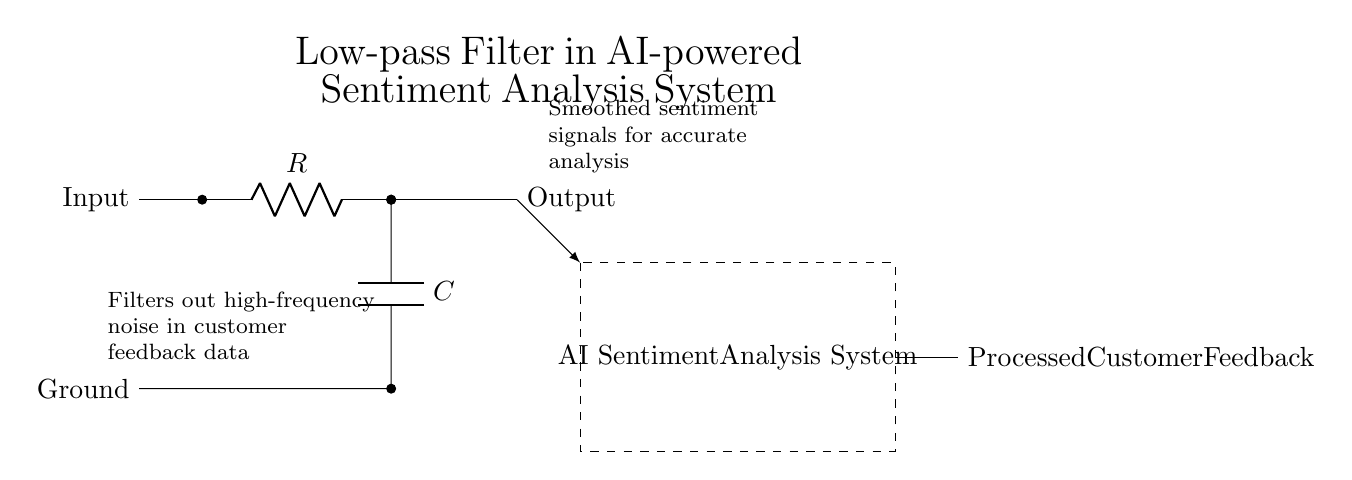What is the input of the circuit? The input is the signal that is fed into the circuit for processing. It is denoted by the label "Input" on the left side of the circuit diagram.
Answer: Input What type of components are used in this circuit? The circuit uses resistors and capacitors, specifically indicated by the symbols for an R and a C in the diagram.
Answer: Resistors and capacitors What does the dashed rectangle represent? The dashed rectangle encloses the AI Sentiment Analysis System, indicating that this is the part of the circuit where the processing occurs after the filtering.
Answer: AI Sentiment Analysis System What is the role of the capacitor in this low-pass filter? The capacitor stores and releases energy, helping smooth out the output signal by filtering out the high-frequency noise from the input signal.
Answer: To smooth the output signal How does this low-pass filter affect the feedback data? The low-pass filter removes high-frequency noise from the customer feedback data, ensuring that only lower frequency signals, which are typically more stable and relevant, are passed through to the analysis system.
Answer: Filters out high-frequency noise What is the output of this circuit? The output is the processed customer feedback that has been filtered and is ready for analysis by the AI Sentiment Analysis System, as indicated on the right side of the circuit diagram.
Answer: Processed Customer Feedback 